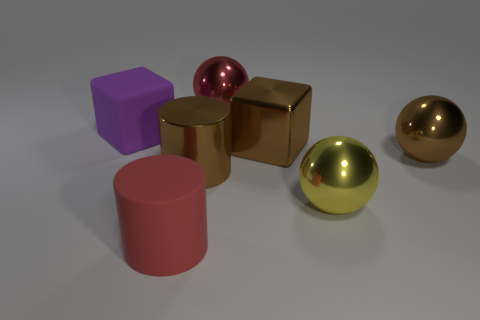Add 1 big brown metallic balls. How many objects exist? 8 Subtract all cylinders. How many objects are left? 5 Subtract all small red matte cylinders. Subtract all brown metallic balls. How many objects are left? 6 Add 5 brown cubes. How many brown cubes are left? 6 Add 4 blue cubes. How many blue cubes exist? 4 Subtract 0 cyan blocks. How many objects are left? 7 